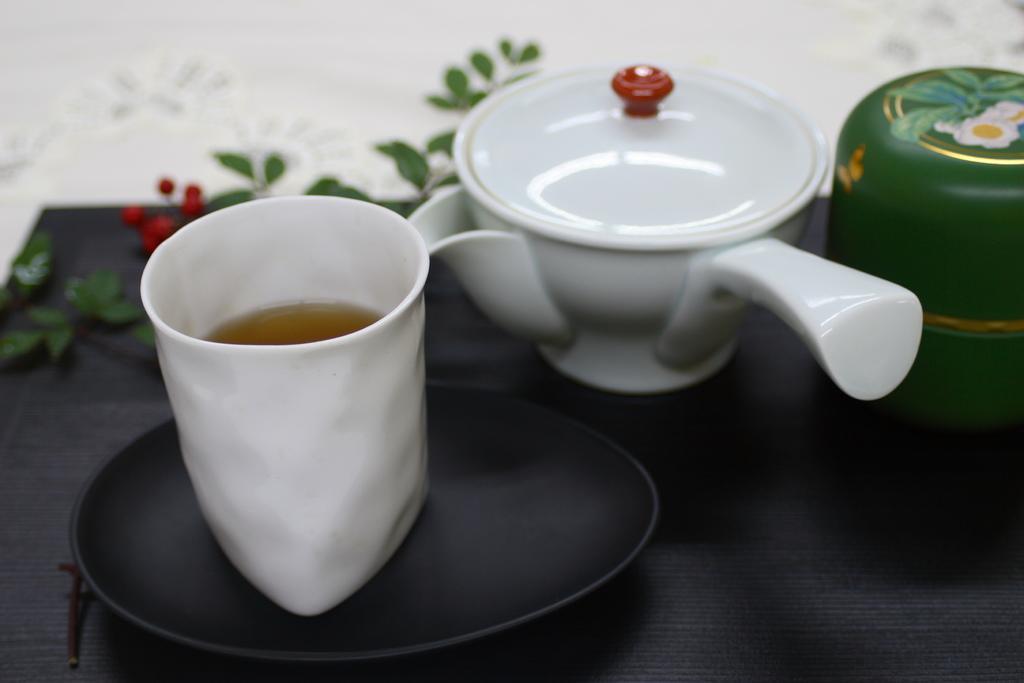In one or two sentences, can you explain what this image depicts? A a kettle and a cup are on a table. 